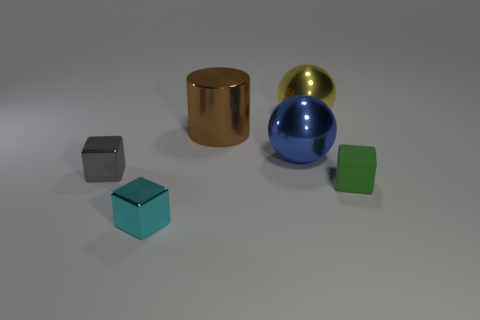Add 2 brown cylinders. How many objects exist? 8 Subtract all spheres. How many objects are left? 4 Subtract 0 brown spheres. How many objects are left? 6 Subtract all small brown cubes. Subtract all brown cylinders. How many objects are left? 5 Add 2 brown objects. How many brown objects are left? 3 Add 1 small yellow metallic blocks. How many small yellow metallic blocks exist? 1 